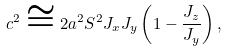Convert formula to latex. <formula><loc_0><loc_0><loc_500><loc_500>c ^ { 2 } \cong 2 a ^ { 2 } S ^ { 2 } J _ { x } J _ { y } \left ( 1 - \frac { J _ { z } } { J _ { y } } \right ) ,</formula> 